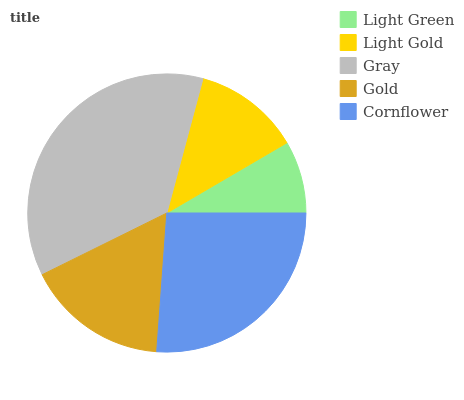Is Light Green the minimum?
Answer yes or no. Yes. Is Gray the maximum?
Answer yes or no. Yes. Is Light Gold the minimum?
Answer yes or no. No. Is Light Gold the maximum?
Answer yes or no. No. Is Light Gold greater than Light Green?
Answer yes or no. Yes. Is Light Green less than Light Gold?
Answer yes or no. Yes. Is Light Green greater than Light Gold?
Answer yes or no. No. Is Light Gold less than Light Green?
Answer yes or no. No. Is Gold the high median?
Answer yes or no. Yes. Is Gold the low median?
Answer yes or no. Yes. Is Cornflower the high median?
Answer yes or no. No. Is Cornflower the low median?
Answer yes or no. No. 